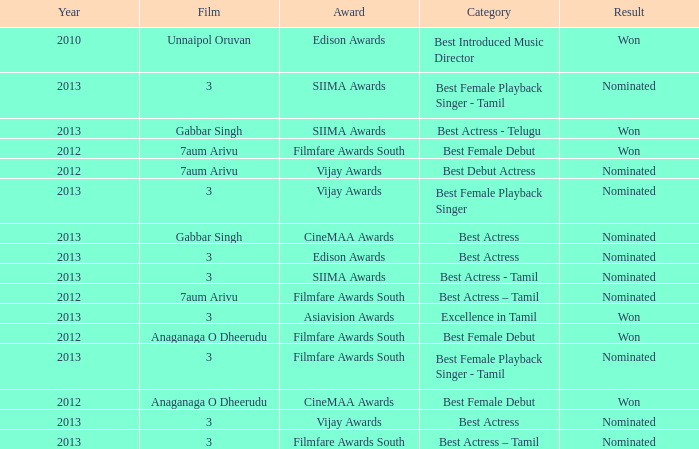What was the result associated with the cinemaa awards, and gabbar singh film? Nominated. 